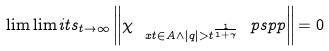Convert formula to latex. <formula><loc_0><loc_0><loc_500><loc_500>\lim \lim i t s _ { t \rightarrow \infty } \left \| \chi _ { \ x t \in A \wedge | q | > t ^ { \frac { 1 } { 1 + \gamma } } } \ p s p p \right \| = 0</formula> 